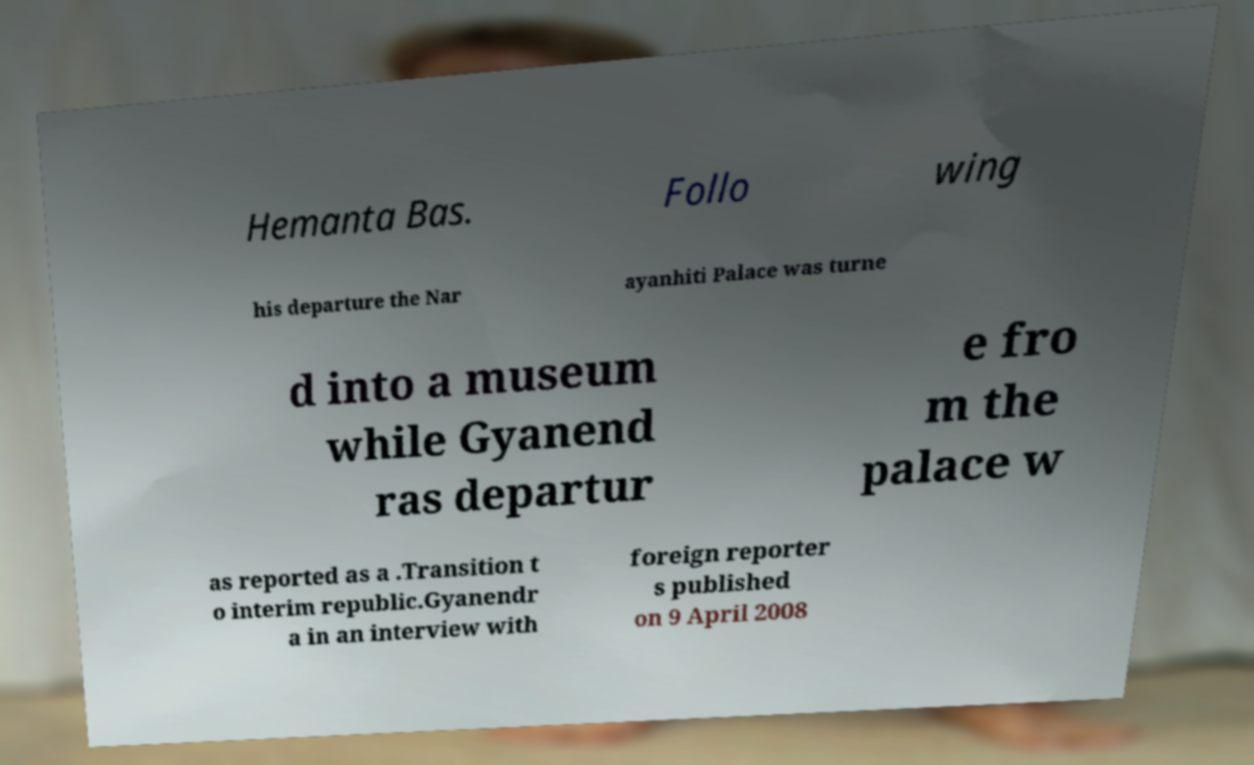Please read and relay the text visible in this image. What does it say? Hemanta Bas. Follo wing his departure the Nar ayanhiti Palace was turne d into a museum while Gyanend ras departur e fro m the palace w as reported as a .Transition t o interim republic.Gyanendr a in an interview with foreign reporter s published on 9 April 2008 